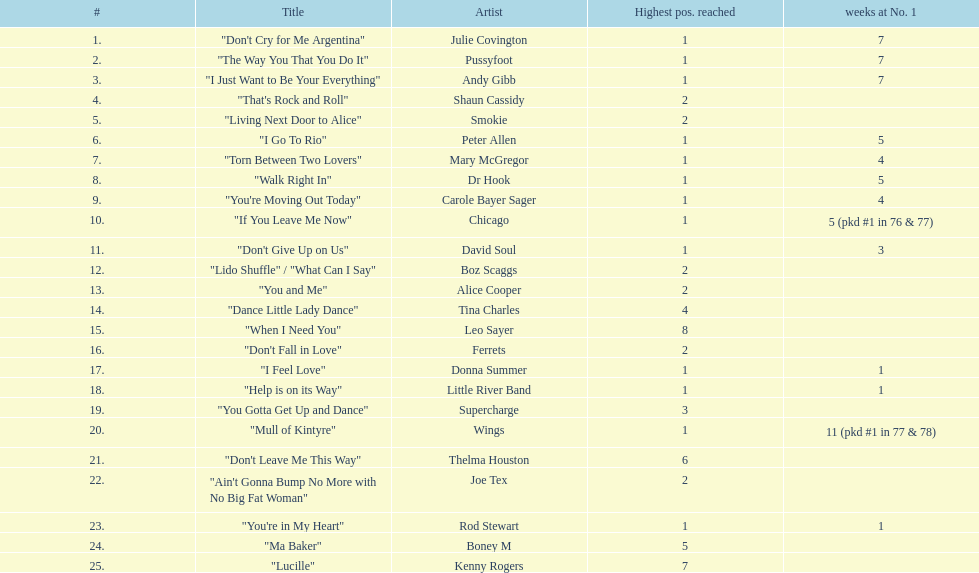Who had the most weeks at number one, according to the table? Wings. 